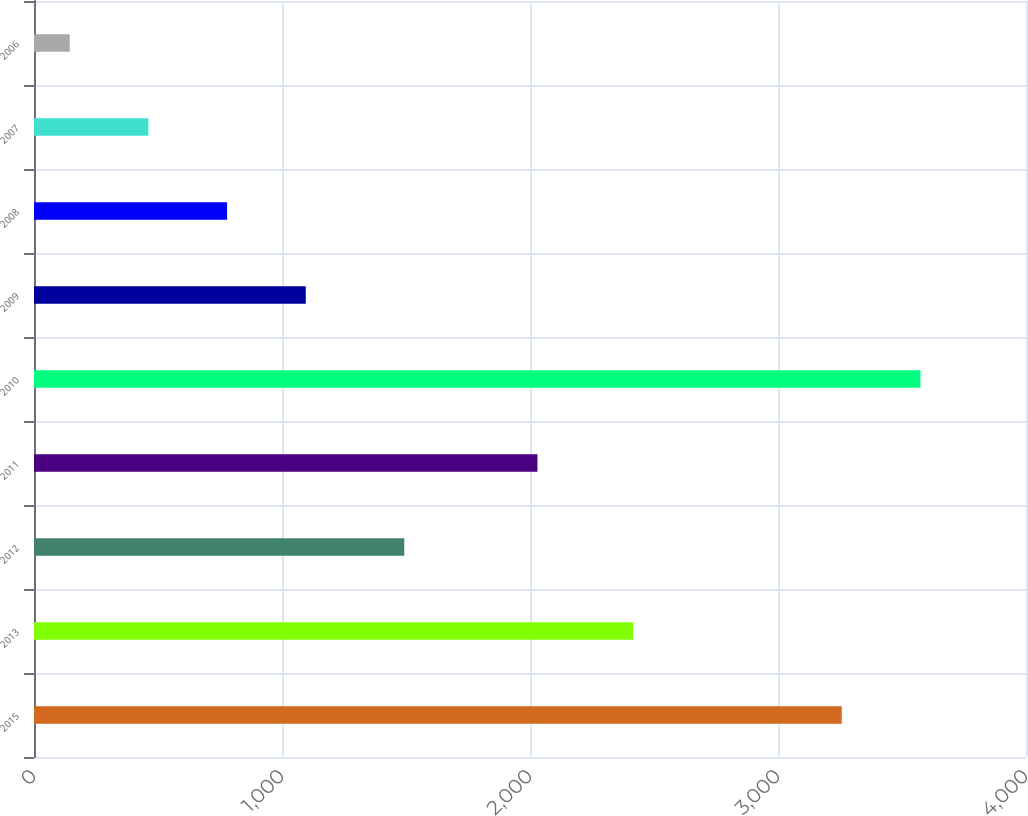<chart> <loc_0><loc_0><loc_500><loc_500><bar_chart><fcel>2015<fcel>2013<fcel>2012<fcel>2011<fcel>2010<fcel>2009<fcel>2008<fcel>2007<fcel>2006<nl><fcel>3257<fcel>2416<fcel>1493<fcel>2030<fcel>3574.3<fcel>1095.9<fcel>778.6<fcel>461.3<fcel>144<nl></chart> 